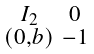Convert formula to latex. <formula><loc_0><loc_0><loc_500><loc_500>\begin{smallmatrix} I _ { 2 } & 0 \\ ( 0 , b ) & - 1 \end{smallmatrix}</formula> 